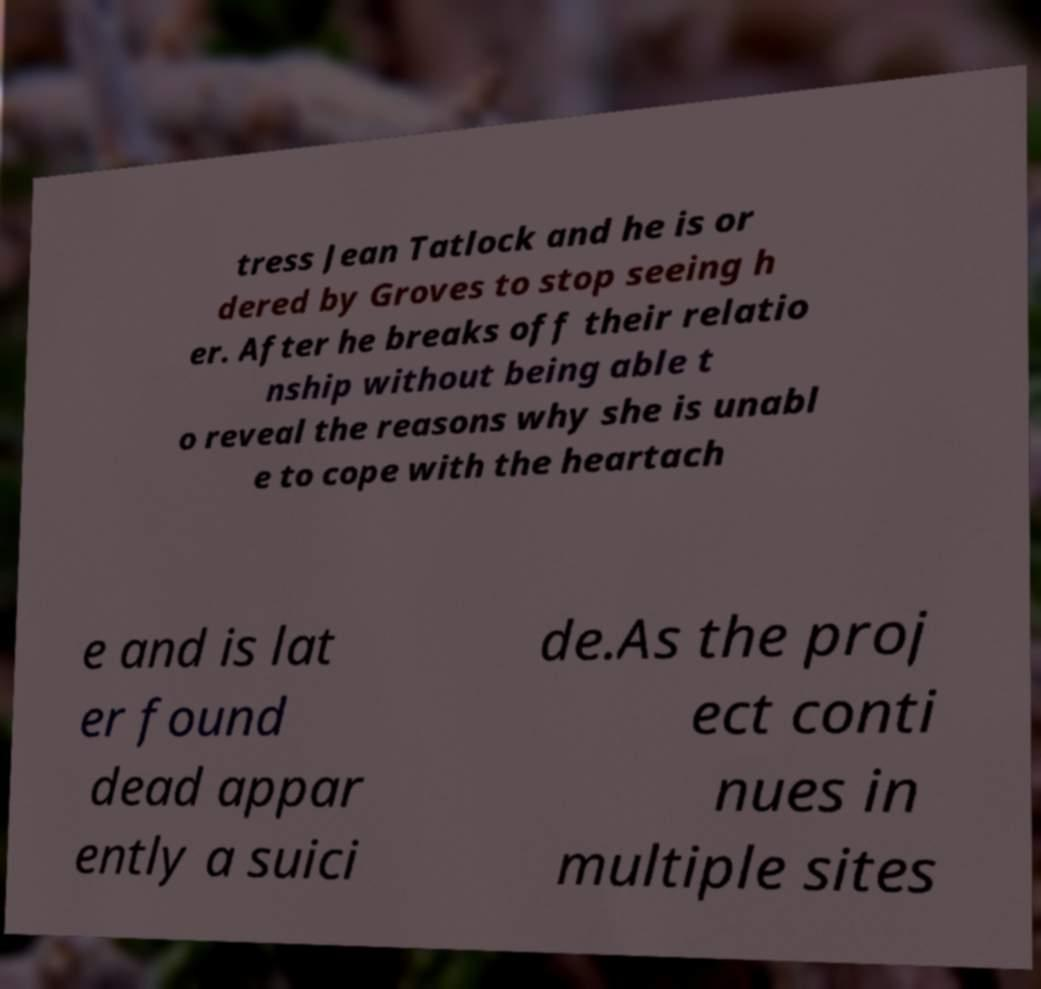For documentation purposes, I need the text within this image transcribed. Could you provide that? tress Jean Tatlock and he is or dered by Groves to stop seeing h er. After he breaks off their relatio nship without being able t o reveal the reasons why she is unabl e to cope with the heartach e and is lat er found dead appar ently a suici de.As the proj ect conti nues in multiple sites 